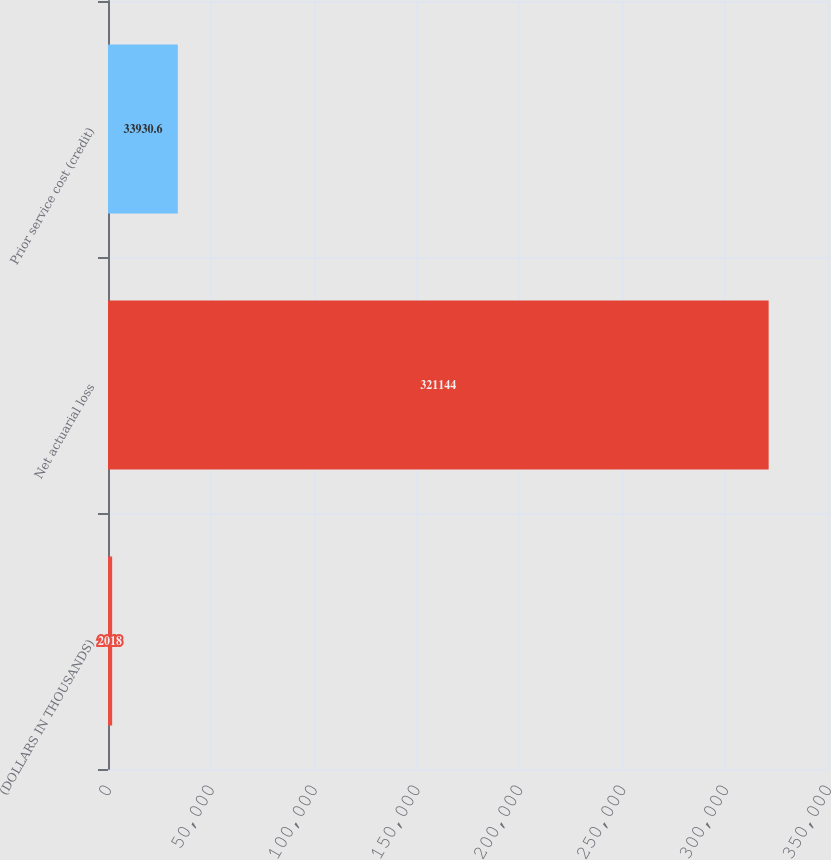Convert chart to OTSL. <chart><loc_0><loc_0><loc_500><loc_500><bar_chart><fcel>(DOLLARS IN THOUSANDS)<fcel>Net actuarial loss<fcel>Prior service cost (credit)<nl><fcel>2018<fcel>321144<fcel>33930.6<nl></chart> 